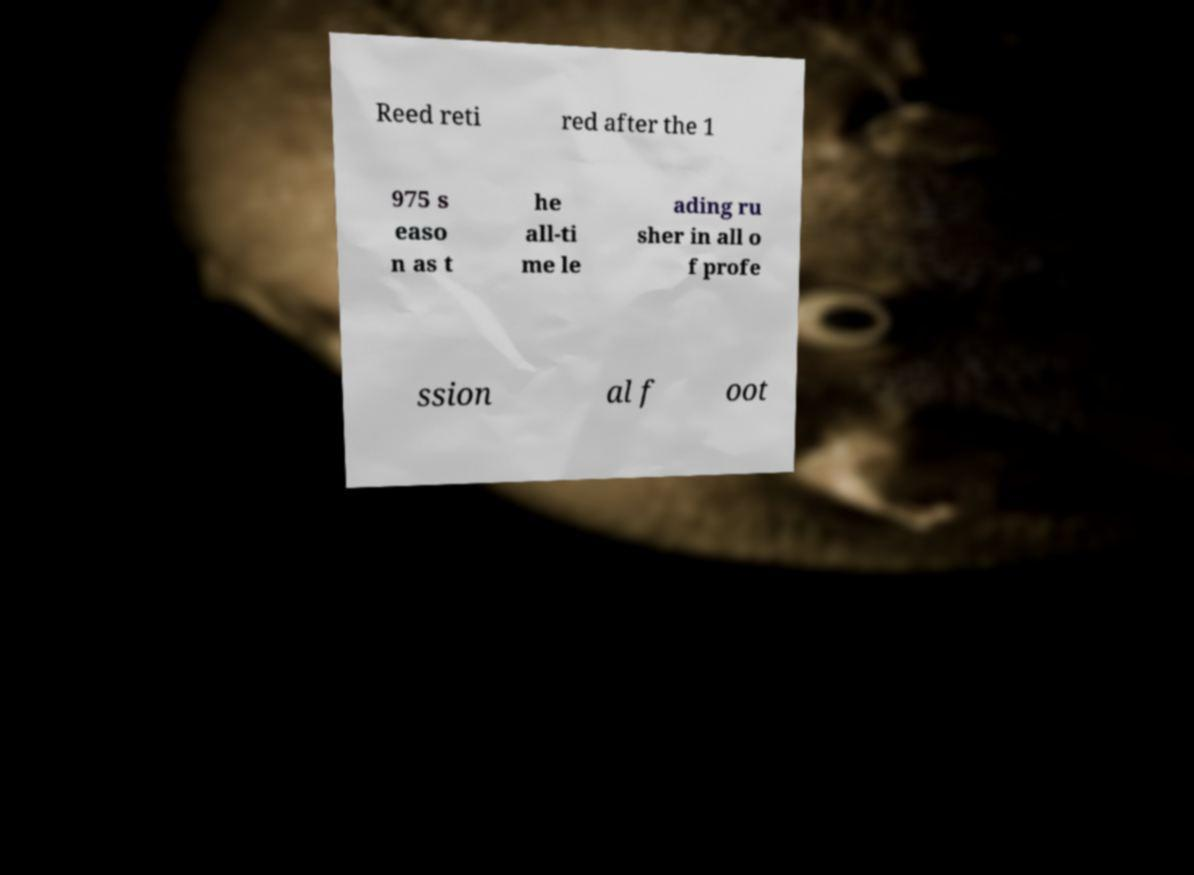For documentation purposes, I need the text within this image transcribed. Could you provide that? Reed reti red after the 1 975 s easo n as t he all-ti me le ading ru sher in all o f profe ssion al f oot 